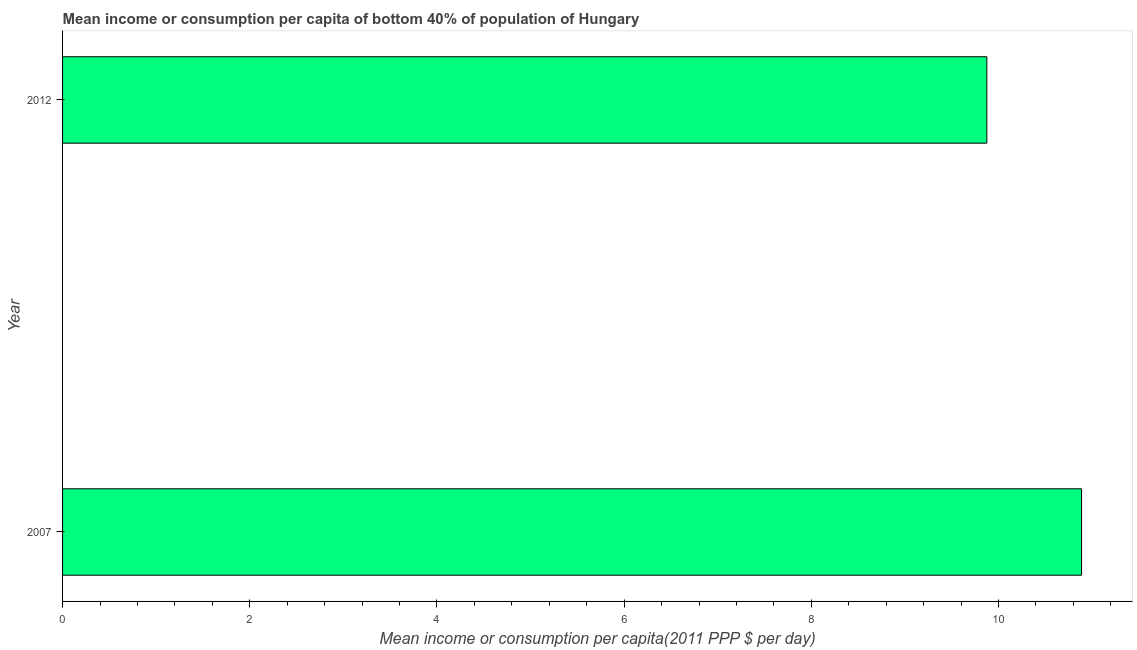Does the graph contain any zero values?
Ensure brevity in your answer.  No. What is the title of the graph?
Offer a terse response. Mean income or consumption per capita of bottom 40% of population of Hungary. What is the label or title of the X-axis?
Ensure brevity in your answer.  Mean income or consumption per capita(2011 PPP $ per day). What is the mean income or consumption in 2012?
Your answer should be very brief. 9.88. Across all years, what is the maximum mean income or consumption?
Offer a very short reply. 10.89. Across all years, what is the minimum mean income or consumption?
Keep it short and to the point. 9.88. In which year was the mean income or consumption minimum?
Offer a terse response. 2012. What is the sum of the mean income or consumption?
Make the answer very short. 20.76. What is the difference between the mean income or consumption in 2007 and 2012?
Your answer should be very brief. 1.01. What is the average mean income or consumption per year?
Your answer should be very brief. 10.38. What is the median mean income or consumption?
Your answer should be compact. 10.38. In how many years, is the mean income or consumption greater than 6.8 $?
Keep it short and to the point. 2. Do a majority of the years between 2007 and 2012 (inclusive) have mean income or consumption greater than 9.2 $?
Keep it short and to the point. Yes. What is the ratio of the mean income or consumption in 2007 to that in 2012?
Offer a very short reply. 1.1. Is the mean income or consumption in 2007 less than that in 2012?
Ensure brevity in your answer.  No. In how many years, is the mean income or consumption greater than the average mean income or consumption taken over all years?
Offer a terse response. 1. What is the Mean income or consumption per capita(2011 PPP $ per day) in 2007?
Your answer should be compact. 10.89. What is the Mean income or consumption per capita(2011 PPP $ per day) in 2012?
Make the answer very short. 9.88. What is the difference between the Mean income or consumption per capita(2011 PPP $ per day) in 2007 and 2012?
Your answer should be very brief. 1.01. What is the ratio of the Mean income or consumption per capita(2011 PPP $ per day) in 2007 to that in 2012?
Make the answer very short. 1.1. 